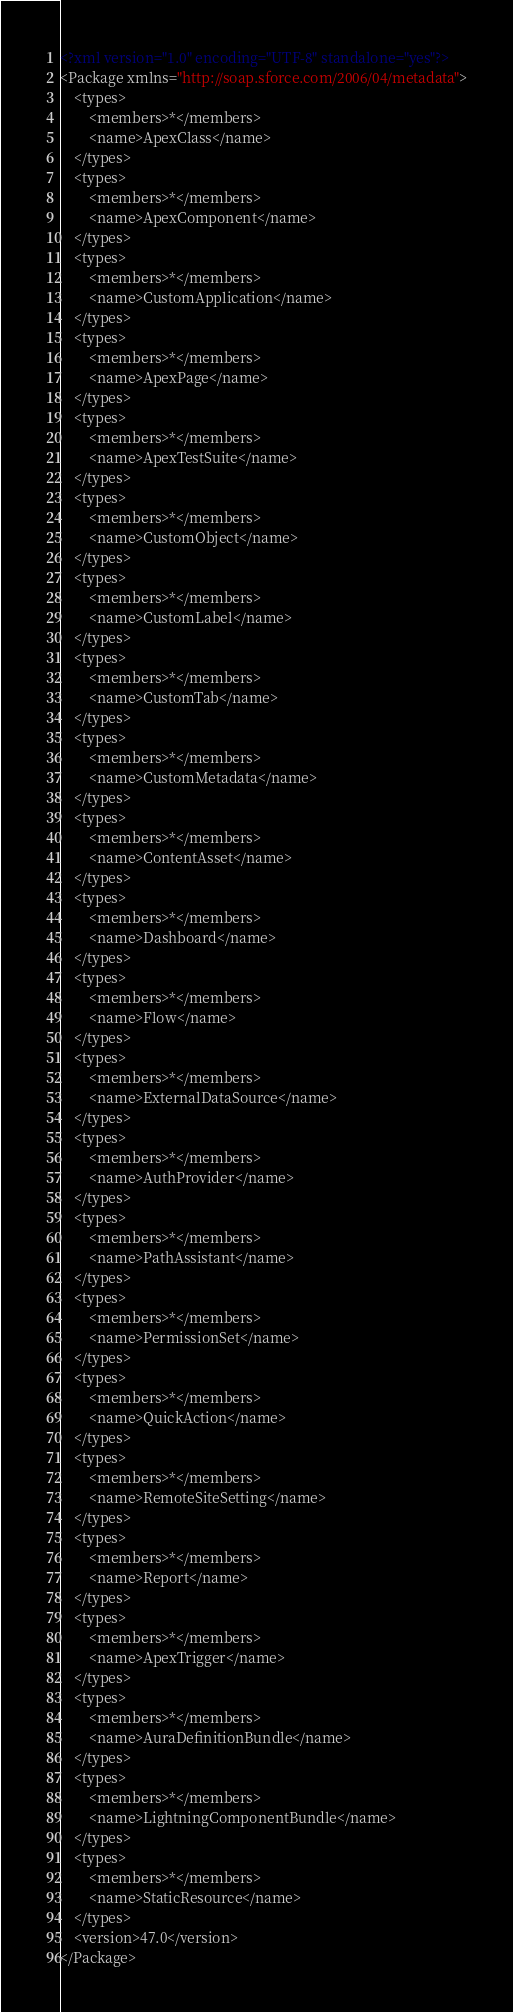Convert code to text. <code><loc_0><loc_0><loc_500><loc_500><_XML_><?xml version="1.0" encoding="UTF-8" standalone="yes"?>
<Package xmlns="http://soap.sforce.com/2006/04/metadata">
    <types>
        <members>*</members>
        <name>ApexClass</name>
    </types>
    <types>
        <members>*</members>
        <name>ApexComponent</name>
    </types>
    <types>
        <members>*</members>
        <name>CustomApplication</name>
    </types>
    <types>
        <members>*</members>
        <name>ApexPage</name>
    </types>
    <types>
        <members>*</members>
        <name>ApexTestSuite</name>
    </types>
    <types>
        <members>*</members>
        <name>CustomObject</name>
    </types>
    <types>
        <members>*</members>
        <name>CustomLabel</name>
    </types>
    <types>
        <members>*</members>
        <name>CustomTab</name>
    </types>
    <types>
        <members>*</members>
        <name>CustomMetadata</name>
    </types>
    <types>
        <members>*</members>
        <name>ContentAsset</name>
    </types>
    <types>
        <members>*</members>
        <name>Dashboard</name>
    </types>
    <types>
        <members>*</members>
        <name>Flow</name>
    </types>
    <types>
        <members>*</members>
        <name>ExternalDataSource</name>
    </types>  
    <types>
        <members>*</members>
        <name>AuthProvider</name>
    </types>    
    <types>
        <members>*</members>
        <name>PathAssistant</name>
    </types>
    <types>
        <members>*</members>
        <name>PermissionSet</name>
    </types>
    <types>
        <members>*</members>
        <name>QuickAction</name>
    </types>
    <types>
        <members>*</members>
        <name>RemoteSiteSetting</name>
    </types>
    <types>
        <members>*</members>
        <name>Report</name>
    </types>
    <types>
        <members>*</members>
        <name>ApexTrigger</name>
    </types>
    <types>
        <members>*</members>
        <name>AuraDefinitionBundle</name>
    </types>
    <types>
        <members>*</members>
        <name>LightningComponentBundle</name>
    </types>
    <types>
        <members>*</members>
        <name>StaticResource</name>
    </types>
    <version>47.0</version>
</Package></code> 